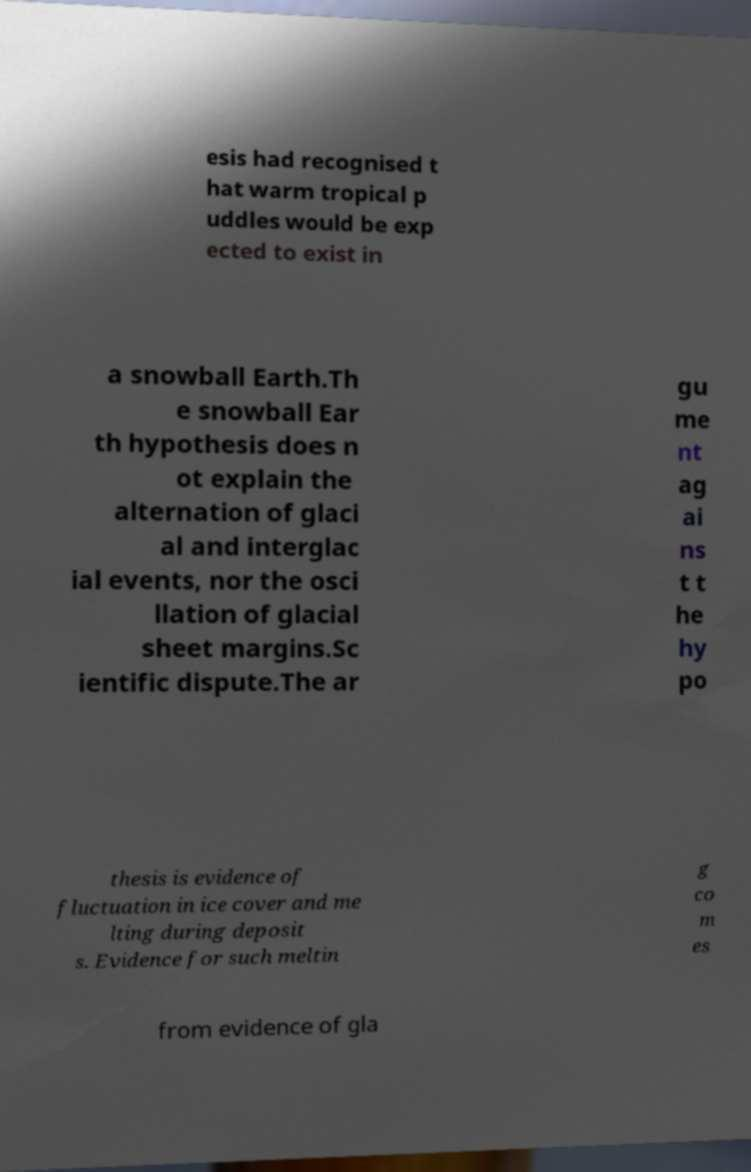Can you read and provide the text displayed in the image?This photo seems to have some interesting text. Can you extract and type it out for me? esis had recognised t hat warm tropical p uddles would be exp ected to exist in a snowball Earth.Th e snowball Ear th hypothesis does n ot explain the alternation of glaci al and interglac ial events, nor the osci llation of glacial sheet margins.Sc ientific dispute.The ar gu me nt ag ai ns t t he hy po thesis is evidence of fluctuation in ice cover and me lting during deposit s. Evidence for such meltin g co m es from evidence of gla 